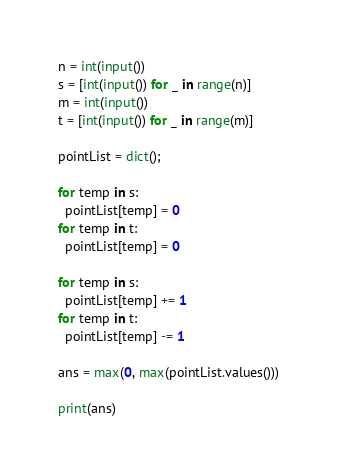<code> <loc_0><loc_0><loc_500><loc_500><_Python_>n = int(input())
s = [int(input()) for _ in range(n)]
m = int(input())
t = [int(input()) for _ in range(m)]

pointList = dict();

for temp in s:
  pointList[temp] = 0
for temp in t:
  pointList[temp] = 0
  
for temp in s:
  pointList[temp] += 1
for temp in t:
  pointList[temp] -= 1
  
ans = max(0, max(pointList.values()))

print(ans)</code> 